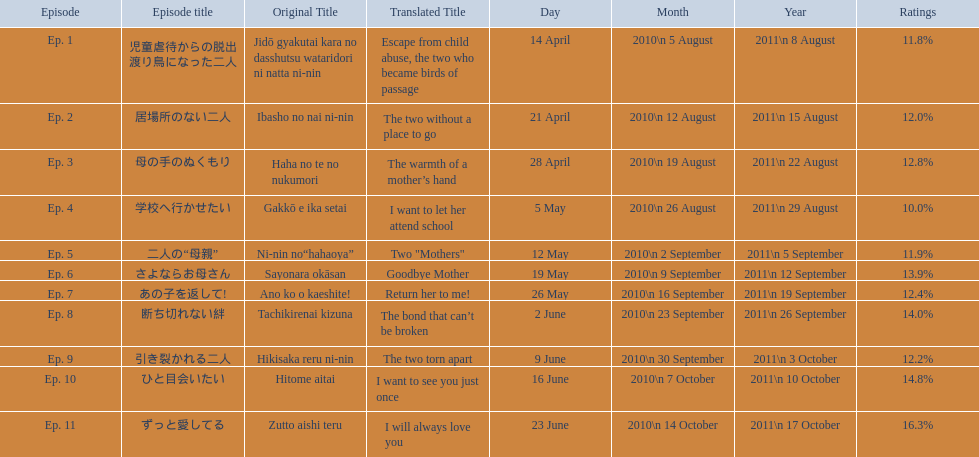What are all of the episode numbers? Ep. 1, Ep. 2, Ep. 3, Ep. 4, Ep. 5, Ep. 6, Ep. 7, Ep. 8, Ep. 9, Ep. 10, Ep. 11. And their titles? 児童虐待からの脱出 渡り鳥になった二人, 居場所のない二人, 母の手のぬくもり, 学校へ行かせたい, 二人の“母親”, さよならお母さん, あの子を返して!, 断ち切れない絆, 引き裂かれる二人, ひと目会いたい, ずっと愛してる. What about their translated names? Escape from child abuse, the two who became birds of passage, The two without a place to go, The warmth of a mother’s hand, I want to let her attend school, Two "Mothers", Goodbye Mother, Return her to me!, The bond that can’t be broken, The two torn apart, I want to see you just once, I will always love you. Which episode number's title translated to i want to let her attend school? Ep. 4. Could you parse the entire table? {'header': ['Episode', 'Episode title', 'Original Title', 'Translated Title', 'Day', 'Month', 'Year', 'Ratings'], 'rows': [['Ep. 1', '児童虐待からの脱出 渡り鳥になった二人', 'Jidō gyakutai kara no dasshutsu wataridori ni natta ni-nin', 'Escape from child abuse, the two who became birds of passage', '14 April', '2010\\n 5 August', '2011\\n 8 August', '11.8%'], ['Ep. 2', '居場所のない二人', 'Ibasho no nai ni-nin', 'The two without a place to go', '21 April', '2010\\n 12 August', '2011\\n 15 August', '12.0%'], ['Ep. 3', '母の手のぬくもり', 'Haha no te no nukumori', 'The warmth of a mother’s hand', '28 April', '2010\\n 19 August', '2011\\n 22 August', '12.8%'], ['Ep. 4', '学校へ行かせたい', 'Gakkō e ika setai', 'I want to let her attend school', '5 May', '2010\\n 26 August', '2011\\n 29 August', '10.0%'], ['Ep. 5', '二人の“母親”', 'Ni-nin no“hahaoya”', 'Two "Mothers"', '12 May', '2010\\n 2 September', '2011\\n 5 September', '11.9%'], ['Ep. 6', 'さよならお母さん', 'Sayonara okāsan', 'Goodbye Mother', '19 May', '2010\\n 9 September', '2011\\n 12 September', '13.9%'], ['Ep. 7', 'あの子を返して!', 'Ano ko o kaeshite!', 'Return her to me!', '26 May', '2010\\n 16 September', '2011\\n 19 September', '12.4%'], ['Ep. 8', '断ち切れない絆', 'Tachikirenai kizuna', 'The bond that can’t be broken', '2 June', '2010\\n 23 September', '2011\\n 26 September', '14.0%'], ['Ep. 9', '引き裂かれる二人', 'Hikisaka reru ni-nin', 'The two torn apart', '9 June', '2010\\n 30 September', '2011\\n 3 October', '12.2%'], ['Ep. 10', 'ひと目会いたい', 'Hitome aitai', 'I want to see you just once', '16 June', '2010\\n 7 October', '2011\\n 10 October', '14.8%'], ['Ep. 11', 'ずっと愛してる', 'Zutto aishi teru', 'I will always love you', '23 June', '2010\\n 14 October', '2011\\n 17 October', '16.3%']]} What were the episode titles of mother? 児童虐待からの脱出 渡り鳥になった二人, 居場所のない二人, 母の手のぬくもり, 学校へ行かせたい, 二人の“母親”, さよならお母さん, あの子を返して!, 断ち切れない絆, 引き裂かれる二人, ひと目会いたい, ずっと愛してる. Which of these episodes had the highest ratings? ずっと愛してる. 